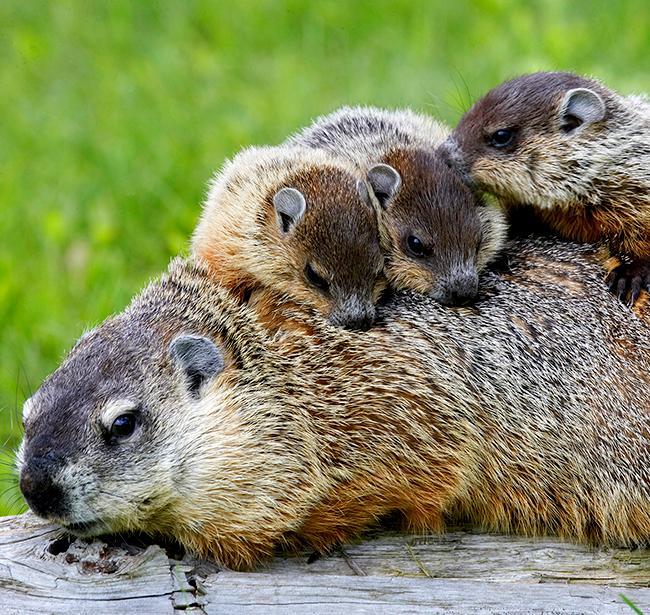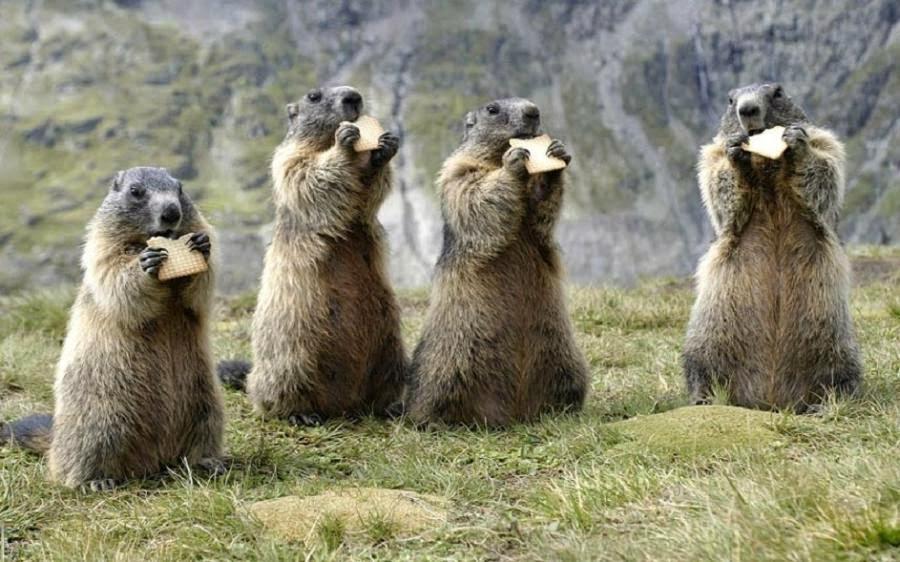The first image is the image on the left, the second image is the image on the right. For the images displayed, is the sentence "At least three marmots are eating." factually correct? Answer yes or no. Yes. The first image is the image on the left, the second image is the image on the right. For the images shown, is this caption "The left and right image contains the same number of prairie dogs." true? Answer yes or no. Yes. 